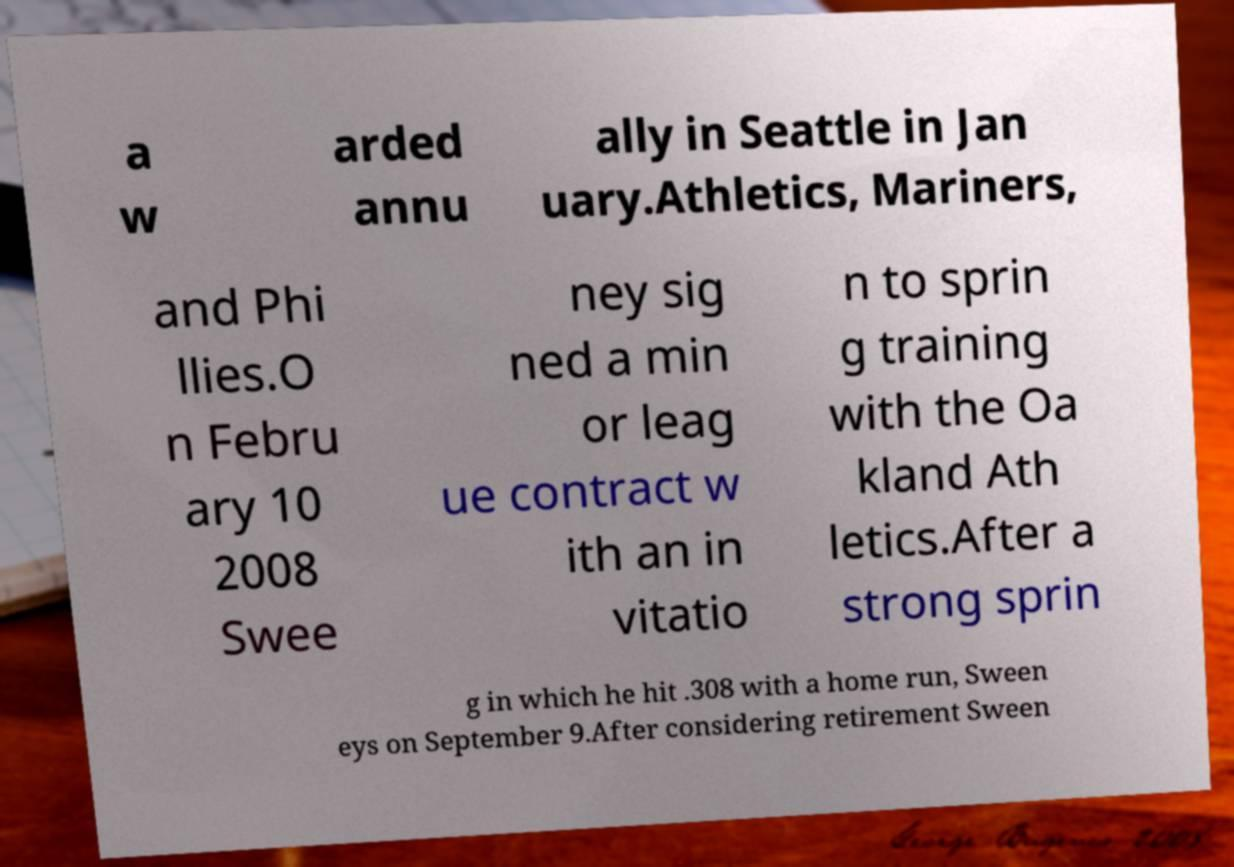Can you read and provide the text displayed in the image?This photo seems to have some interesting text. Can you extract and type it out for me? a w arded annu ally in Seattle in Jan uary.Athletics, Mariners, and Phi llies.O n Febru ary 10 2008 Swee ney sig ned a min or leag ue contract w ith an in vitatio n to sprin g training with the Oa kland Ath letics.After a strong sprin g in which he hit .308 with a home run, Sween eys on September 9.After considering retirement Sween 